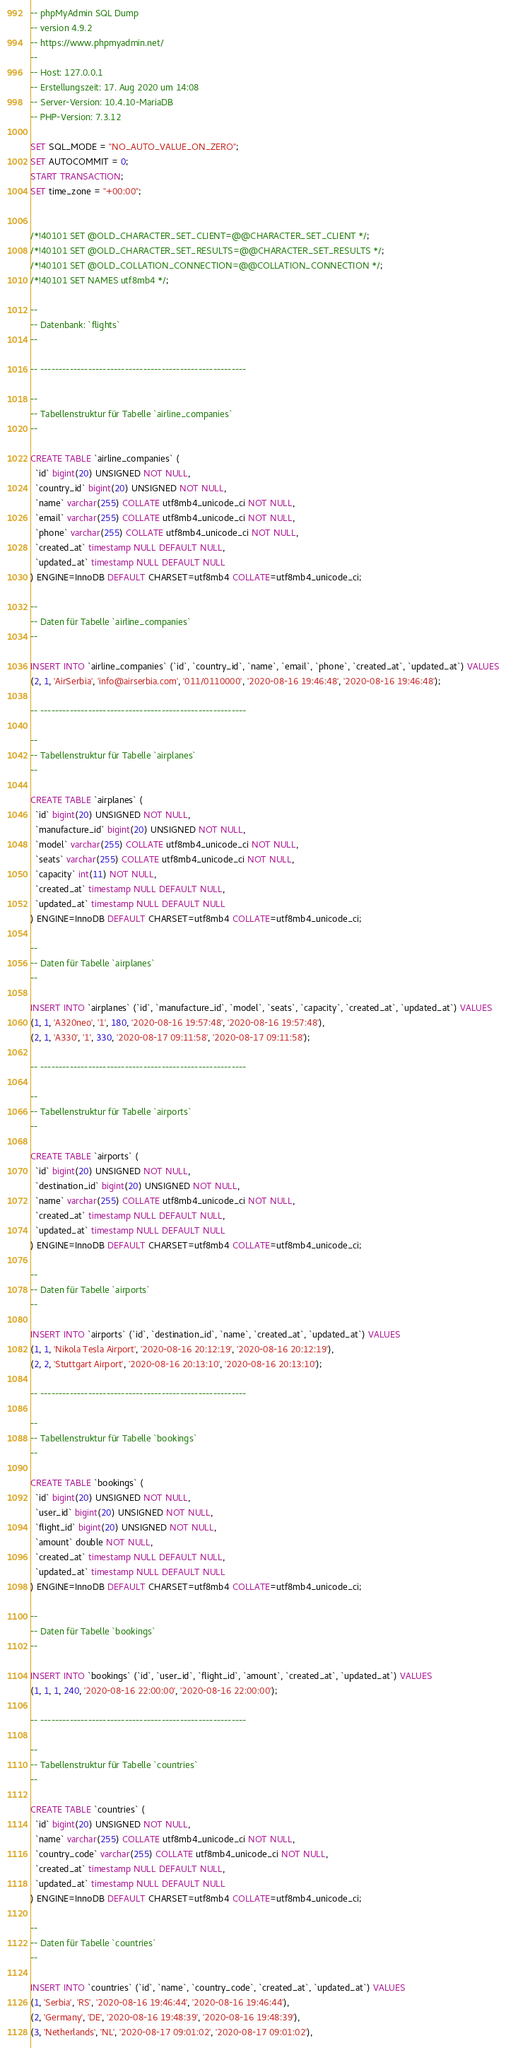<code> <loc_0><loc_0><loc_500><loc_500><_SQL_>-- phpMyAdmin SQL Dump
-- version 4.9.2
-- https://www.phpmyadmin.net/
--
-- Host: 127.0.0.1
-- Erstellungszeit: 17. Aug 2020 um 14:08
-- Server-Version: 10.4.10-MariaDB
-- PHP-Version: 7.3.12

SET SQL_MODE = "NO_AUTO_VALUE_ON_ZERO";
SET AUTOCOMMIT = 0;
START TRANSACTION;
SET time_zone = "+00:00";


/*!40101 SET @OLD_CHARACTER_SET_CLIENT=@@CHARACTER_SET_CLIENT */;
/*!40101 SET @OLD_CHARACTER_SET_RESULTS=@@CHARACTER_SET_RESULTS */;
/*!40101 SET @OLD_COLLATION_CONNECTION=@@COLLATION_CONNECTION */;
/*!40101 SET NAMES utf8mb4 */;

--
-- Datenbank: `flights`
--

-- --------------------------------------------------------

--
-- Tabellenstruktur für Tabelle `airline_companies`
--

CREATE TABLE `airline_companies` (
  `id` bigint(20) UNSIGNED NOT NULL,
  `country_id` bigint(20) UNSIGNED NOT NULL,
  `name` varchar(255) COLLATE utf8mb4_unicode_ci NOT NULL,
  `email` varchar(255) COLLATE utf8mb4_unicode_ci NOT NULL,
  `phone` varchar(255) COLLATE utf8mb4_unicode_ci NOT NULL,
  `created_at` timestamp NULL DEFAULT NULL,
  `updated_at` timestamp NULL DEFAULT NULL
) ENGINE=InnoDB DEFAULT CHARSET=utf8mb4 COLLATE=utf8mb4_unicode_ci;

--
-- Daten für Tabelle `airline_companies`
--

INSERT INTO `airline_companies` (`id`, `country_id`, `name`, `email`, `phone`, `created_at`, `updated_at`) VALUES
(2, 1, 'AirSerbia', 'info@airserbia.com', '011/0110000', '2020-08-16 19:46:48', '2020-08-16 19:46:48');

-- --------------------------------------------------------

--
-- Tabellenstruktur für Tabelle `airplanes`
--

CREATE TABLE `airplanes` (
  `id` bigint(20) UNSIGNED NOT NULL,
  `manufacture_id` bigint(20) UNSIGNED NOT NULL,
  `model` varchar(255) COLLATE utf8mb4_unicode_ci NOT NULL,
  `seats` varchar(255) COLLATE utf8mb4_unicode_ci NOT NULL,
  `capacity` int(11) NOT NULL,
  `created_at` timestamp NULL DEFAULT NULL,
  `updated_at` timestamp NULL DEFAULT NULL
) ENGINE=InnoDB DEFAULT CHARSET=utf8mb4 COLLATE=utf8mb4_unicode_ci;

--
-- Daten für Tabelle `airplanes`
--

INSERT INTO `airplanes` (`id`, `manufacture_id`, `model`, `seats`, `capacity`, `created_at`, `updated_at`) VALUES
(1, 1, 'A320neo', '1', 180, '2020-08-16 19:57:48', '2020-08-16 19:57:48'),
(2, 1, 'A330', '1', 330, '2020-08-17 09:11:58', '2020-08-17 09:11:58');

-- --------------------------------------------------------

--
-- Tabellenstruktur für Tabelle `airports`
--

CREATE TABLE `airports` (
  `id` bigint(20) UNSIGNED NOT NULL,
  `destination_id` bigint(20) UNSIGNED NOT NULL,
  `name` varchar(255) COLLATE utf8mb4_unicode_ci NOT NULL,
  `created_at` timestamp NULL DEFAULT NULL,
  `updated_at` timestamp NULL DEFAULT NULL
) ENGINE=InnoDB DEFAULT CHARSET=utf8mb4 COLLATE=utf8mb4_unicode_ci;

--
-- Daten für Tabelle `airports`
--

INSERT INTO `airports` (`id`, `destination_id`, `name`, `created_at`, `updated_at`) VALUES
(1, 1, 'Nikola Tesla Airport', '2020-08-16 20:12:19', '2020-08-16 20:12:19'),
(2, 2, 'Stuttgart Airport', '2020-08-16 20:13:10', '2020-08-16 20:13:10');

-- --------------------------------------------------------

--
-- Tabellenstruktur für Tabelle `bookings`
--

CREATE TABLE `bookings` (
  `id` bigint(20) UNSIGNED NOT NULL,
  `user_id` bigint(20) UNSIGNED NOT NULL,
  `flight_id` bigint(20) UNSIGNED NOT NULL,
  `amount` double NOT NULL,
  `created_at` timestamp NULL DEFAULT NULL,
  `updated_at` timestamp NULL DEFAULT NULL
) ENGINE=InnoDB DEFAULT CHARSET=utf8mb4 COLLATE=utf8mb4_unicode_ci;

--
-- Daten für Tabelle `bookings`
--

INSERT INTO `bookings` (`id`, `user_id`, `flight_id`, `amount`, `created_at`, `updated_at`) VALUES
(1, 1, 1, 240, '2020-08-16 22:00:00', '2020-08-16 22:00:00');

-- --------------------------------------------------------

--
-- Tabellenstruktur für Tabelle `countries`
--

CREATE TABLE `countries` (
  `id` bigint(20) UNSIGNED NOT NULL,
  `name` varchar(255) COLLATE utf8mb4_unicode_ci NOT NULL,
  `country_code` varchar(255) COLLATE utf8mb4_unicode_ci NOT NULL,
  `created_at` timestamp NULL DEFAULT NULL,
  `updated_at` timestamp NULL DEFAULT NULL
) ENGINE=InnoDB DEFAULT CHARSET=utf8mb4 COLLATE=utf8mb4_unicode_ci;

--
-- Daten für Tabelle `countries`
--

INSERT INTO `countries` (`id`, `name`, `country_code`, `created_at`, `updated_at`) VALUES
(1, 'Serbia', 'RS', '2020-08-16 19:46:44', '2020-08-16 19:46:44'),
(2, 'Germany', 'DE', '2020-08-16 19:48:39', '2020-08-16 19:48:39'),
(3, 'Netherlands', 'NL', '2020-08-17 09:01:02', '2020-08-17 09:01:02'),</code> 